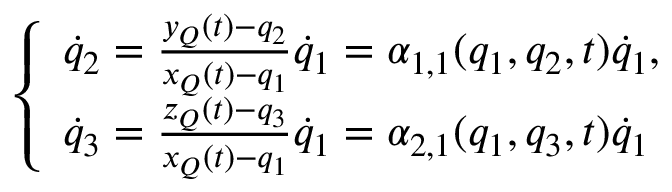<formula> <loc_0><loc_0><loc_500><loc_500>\left \{ \begin{array} { l } { { \dot { q } } _ { 2 } = \frac { y _ { Q } ( t ) - q _ { 2 } } { x _ { Q } ( t ) - q _ { 1 } } { \dot { q } } _ { 1 } = \alpha _ { 1 , 1 } ( q _ { 1 } , q _ { 2 } , t ) { \dot { q } } _ { 1 } , } \\ { { \dot { q } } _ { 3 } = \frac { z _ { Q } ( t ) - q _ { 3 } } { x _ { Q } ( t ) - q _ { 1 } } { \dot { q } } _ { 1 } = \alpha _ { 2 , 1 } ( q _ { 1 } , q _ { 3 } , t ) { \dot { q } } _ { 1 } } \end{array}</formula> 